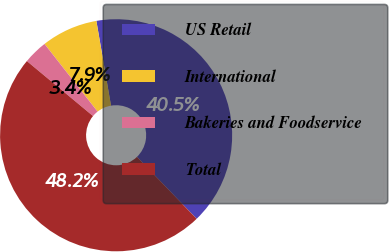<chart> <loc_0><loc_0><loc_500><loc_500><pie_chart><fcel>US Retail<fcel>International<fcel>Bakeries and Foodservice<fcel>Total<nl><fcel>40.52%<fcel>7.86%<fcel>3.38%<fcel>48.24%<nl></chart> 